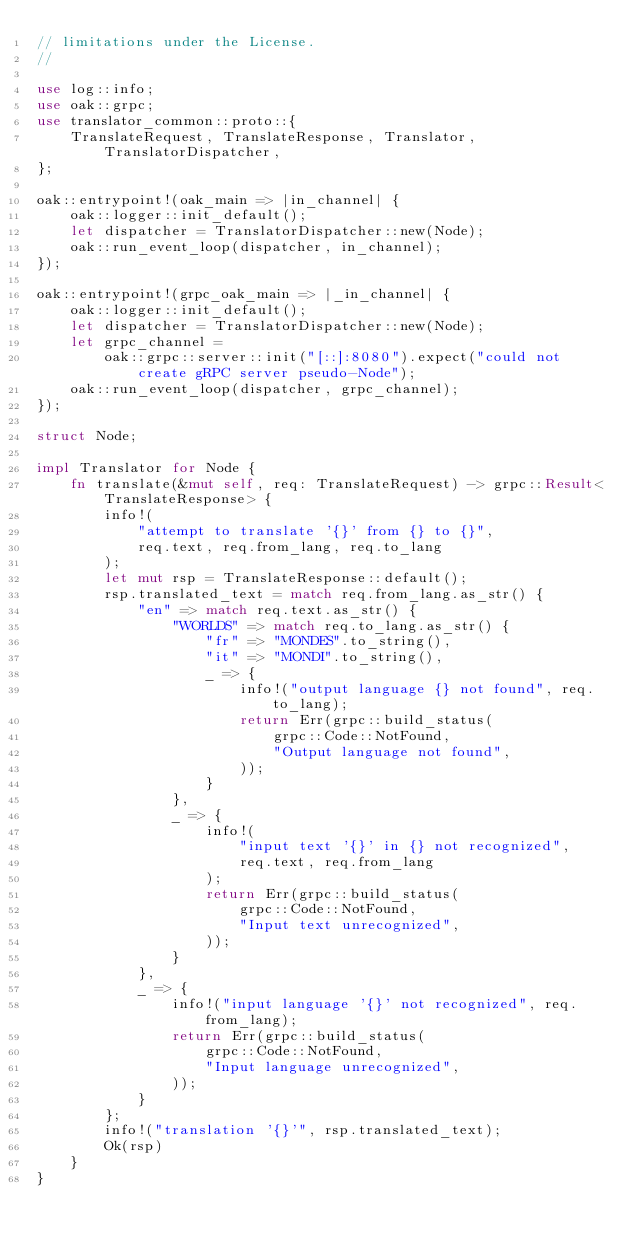Convert code to text. <code><loc_0><loc_0><loc_500><loc_500><_Rust_>// limitations under the License.
//

use log::info;
use oak::grpc;
use translator_common::proto::{
    TranslateRequest, TranslateResponse, Translator, TranslatorDispatcher,
};

oak::entrypoint!(oak_main => |in_channel| {
    oak::logger::init_default();
    let dispatcher = TranslatorDispatcher::new(Node);
    oak::run_event_loop(dispatcher, in_channel);
});

oak::entrypoint!(grpc_oak_main => |_in_channel| {
    oak::logger::init_default();
    let dispatcher = TranslatorDispatcher::new(Node);
    let grpc_channel =
        oak::grpc::server::init("[::]:8080").expect("could not create gRPC server pseudo-Node");
    oak::run_event_loop(dispatcher, grpc_channel);
});

struct Node;

impl Translator for Node {
    fn translate(&mut self, req: TranslateRequest) -> grpc::Result<TranslateResponse> {
        info!(
            "attempt to translate '{}' from {} to {}",
            req.text, req.from_lang, req.to_lang
        );
        let mut rsp = TranslateResponse::default();
        rsp.translated_text = match req.from_lang.as_str() {
            "en" => match req.text.as_str() {
                "WORLDS" => match req.to_lang.as_str() {
                    "fr" => "MONDES".to_string(),
                    "it" => "MONDI".to_string(),
                    _ => {
                        info!("output language {} not found", req.to_lang);
                        return Err(grpc::build_status(
                            grpc::Code::NotFound,
                            "Output language not found",
                        ));
                    }
                },
                _ => {
                    info!(
                        "input text '{}' in {} not recognized",
                        req.text, req.from_lang
                    );
                    return Err(grpc::build_status(
                        grpc::Code::NotFound,
                        "Input text unrecognized",
                    ));
                }
            },
            _ => {
                info!("input language '{}' not recognized", req.from_lang);
                return Err(grpc::build_status(
                    grpc::Code::NotFound,
                    "Input language unrecognized",
                ));
            }
        };
        info!("translation '{}'", rsp.translated_text);
        Ok(rsp)
    }
}
</code> 